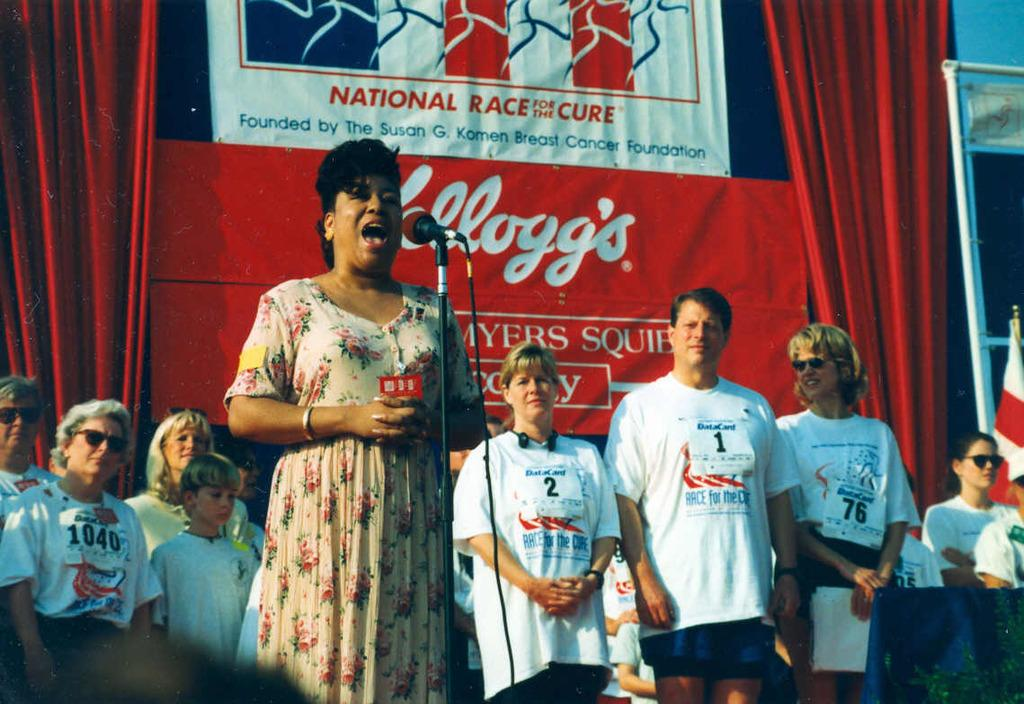<image>
Offer a succinct explanation of the picture presented. Woman singing into a microphone in front of a banner that says "Kelloggs". 